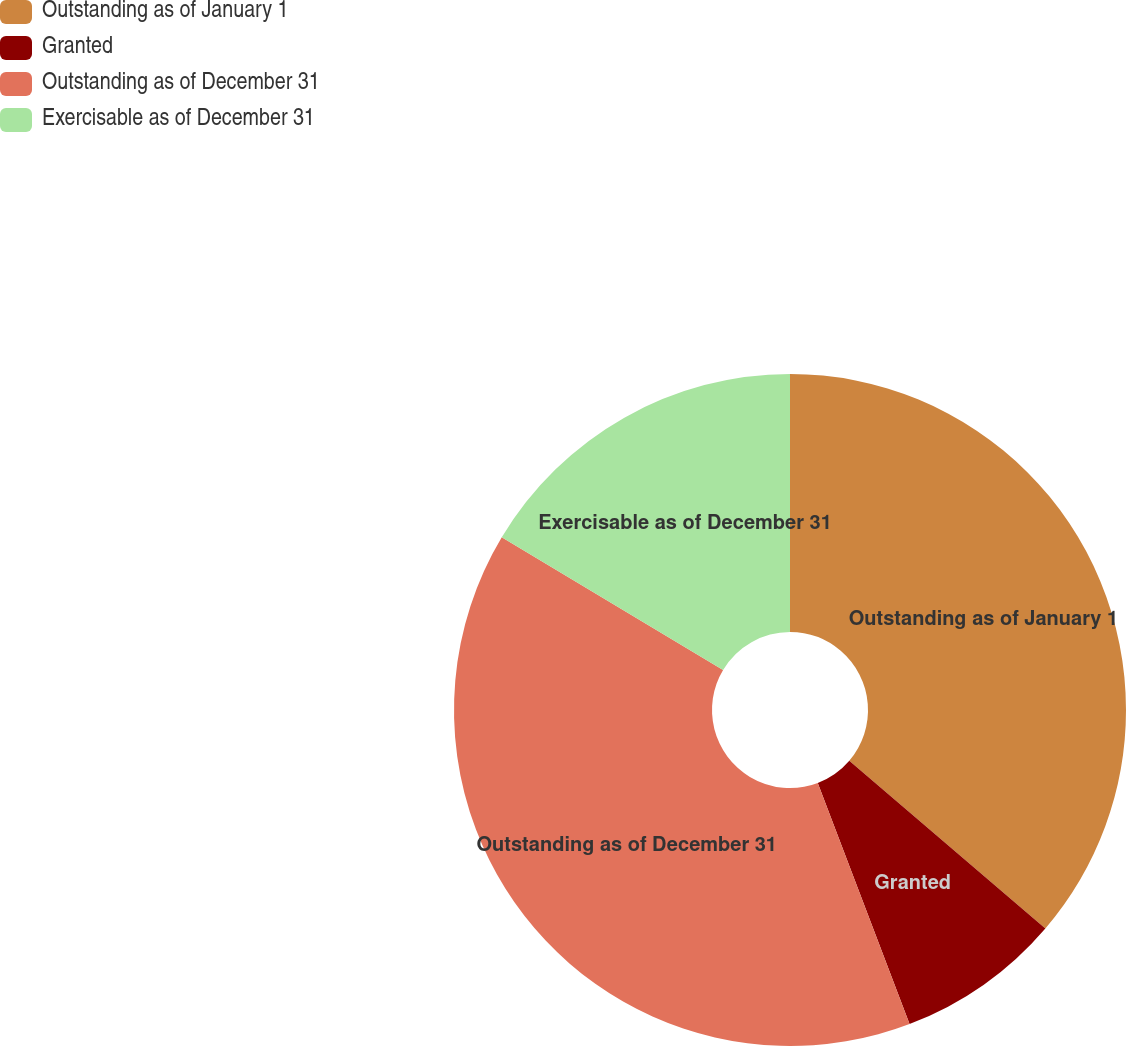<chart> <loc_0><loc_0><loc_500><loc_500><pie_chart><fcel>Outstanding as of January 1<fcel>Granted<fcel>Outstanding as of December 31<fcel>Exercisable as of December 31<nl><fcel>36.26%<fcel>7.95%<fcel>39.38%<fcel>16.41%<nl></chart> 